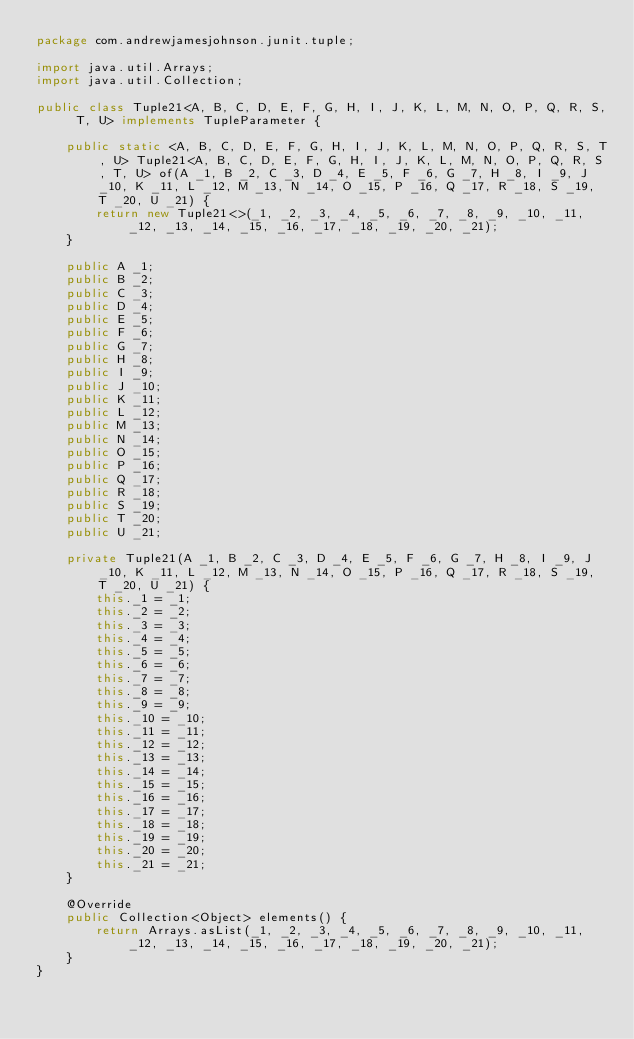Convert code to text. <code><loc_0><loc_0><loc_500><loc_500><_Java_>package com.andrewjamesjohnson.junit.tuple;

import java.util.Arrays;
import java.util.Collection;

public class Tuple21<A, B, C, D, E, F, G, H, I, J, K, L, M, N, O, P, Q, R, S, T, U> implements TupleParameter {

    public static <A, B, C, D, E, F, G, H, I, J, K, L, M, N, O, P, Q, R, S, T, U> Tuple21<A, B, C, D, E, F, G, H, I, J, K, L, M, N, O, P, Q, R, S, T, U> of(A _1, B _2, C _3, D _4, E _5, F _6, G _7, H _8, I _9, J _10, K _11, L _12, M _13, N _14, O _15, P _16, Q _17, R _18, S _19, T _20, U _21) {
        return new Tuple21<>(_1, _2, _3, _4, _5, _6, _7, _8, _9, _10, _11, _12, _13, _14, _15, _16, _17, _18, _19, _20, _21);
    }

    public A _1;
    public B _2;
    public C _3;
    public D _4;
    public E _5;
    public F _6;
    public G _7;
    public H _8;
    public I _9;
    public J _10;
    public K _11;
    public L _12;
    public M _13;
    public N _14;
    public O _15;
    public P _16;
    public Q _17;
    public R _18;
    public S _19;
    public T _20;
    public U _21;

    private Tuple21(A _1, B _2, C _3, D _4, E _5, F _6, G _7, H _8, I _9, J _10, K _11, L _12, M _13, N _14, O _15, P _16, Q _17, R _18, S _19, T _20, U _21) {
        this._1 = _1;
        this._2 = _2;
        this._3 = _3;
        this._4 = _4;
        this._5 = _5;
        this._6 = _6;
        this._7 = _7;
        this._8 = _8;
        this._9 = _9;
        this._10 = _10;
        this._11 = _11;
        this._12 = _12;
        this._13 = _13;
        this._14 = _14;
        this._15 = _15;
        this._16 = _16;
        this._17 = _17;
        this._18 = _18;
        this._19 = _19;
        this._20 = _20;
        this._21 = _21;
    }

    @Override
    public Collection<Object> elements() {
        return Arrays.asList(_1, _2, _3, _4, _5, _6, _7, _8, _9, _10, _11, _12, _13, _14, _15, _16, _17, _18, _19, _20, _21);
    }
}</code> 